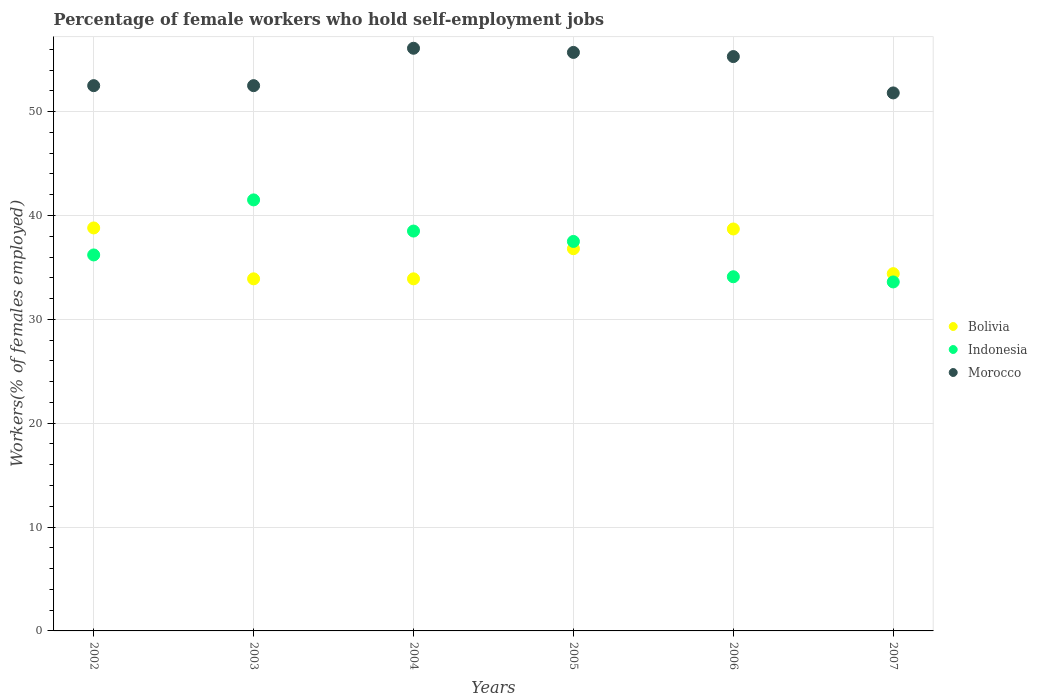Is the number of dotlines equal to the number of legend labels?
Ensure brevity in your answer.  Yes. What is the percentage of self-employed female workers in Morocco in 2002?
Your response must be concise. 52.5. Across all years, what is the maximum percentage of self-employed female workers in Bolivia?
Your answer should be compact. 38.8. Across all years, what is the minimum percentage of self-employed female workers in Indonesia?
Offer a very short reply. 33.6. In which year was the percentage of self-employed female workers in Bolivia maximum?
Your response must be concise. 2002. What is the total percentage of self-employed female workers in Bolivia in the graph?
Offer a terse response. 216.5. What is the difference between the percentage of self-employed female workers in Morocco in 2002 and that in 2006?
Your answer should be compact. -2.8. What is the difference between the percentage of self-employed female workers in Morocco in 2003 and the percentage of self-employed female workers in Indonesia in 2007?
Your answer should be compact. 18.9. What is the average percentage of self-employed female workers in Bolivia per year?
Ensure brevity in your answer.  36.08. In the year 2002, what is the difference between the percentage of self-employed female workers in Indonesia and percentage of self-employed female workers in Morocco?
Offer a very short reply. -16.3. In how many years, is the percentage of self-employed female workers in Bolivia greater than 10 %?
Provide a short and direct response. 6. What is the ratio of the percentage of self-employed female workers in Indonesia in 2003 to that in 2006?
Keep it short and to the point. 1.22. What is the difference between the highest and the second highest percentage of self-employed female workers in Bolivia?
Your answer should be compact. 0.1. What is the difference between the highest and the lowest percentage of self-employed female workers in Morocco?
Ensure brevity in your answer.  4.3. Does the percentage of self-employed female workers in Indonesia monotonically increase over the years?
Make the answer very short. No. Is the percentage of self-employed female workers in Morocco strictly greater than the percentage of self-employed female workers in Indonesia over the years?
Make the answer very short. Yes. Is the percentage of self-employed female workers in Indonesia strictly less than the percentage of self-employed female workers in Morocco over the years?
Keep it short and to the point. Yes. How many dotlines are there?
Your answer should be compact. 3. How many years are there in the graph?
Offer a very short reply. 6. Are the values on the major ticks of Y-axis written in scientific E-notation?
Your answer should be compact. No. Does the graph contain any zero values?
Your answer should be very brief. No. Does the graph contain grids?
Your answer should be very brief. Yes. Where does the legend appear in the graph?
Offer a very short reply. Center right. How many legend labels are there?
Give a very brief answer. 3. What is the title of the graph?
Your answer should be very brief. Percentage of female workers who hold self-employment jobs. What is the label or title of the Y-axis?
Keep it short and to the point. Workers(% of females employed). What is the Workers(% of females employed) of Bolivia in 2002?
Give a very brief answer. 38.8. What is the Workers(% of females employed) of Indonesia in 2002?
Make the answer very short. 36.2. What is the Workers(% of females employed) of Morocco in 2002?
Make the answer very short. 52.5. What is the Workers(% of females employed) in Bolivia in 2003?
Your response must be concise. 33.9. What is the Workers(% of females employed) of Indonesia in 2003?
Offer a terse response. 41.5. What is the Workers(% of females employed) of Morocco in 2003?
Ensure brevity in your answer.  52.5. What is the Workers(% of females employed) of Bolivia in 2004?
Your answer should be very brief. 33.9. What is the Workers(% of females employed) in Indonesia in 2004?
Provide a succinct answer. 38.5. What is the Workers(% of females employed) in Morocco in 2004?
Your answer should be very brief. 56.1. What is the Workers(% of females employed) in Bolivia in 2005?
Your answer should be very brief. 36.8. What is the Workers(% of females employed) in Indonesia in 2005?
Offer a terse response. 37.5. What is the Workers(% of females employed) in Morocco in 2005?
Offer a terse response. 55.7. What is the Workers(% of females employed) in Bolivia in 2006?
Provide a succinct answer. 38.7. What is the Workers(% of females employed) in Indonesia in 2006?
Keep it short and to the point. 34.1. What is the Workers(% of females employed) in Morocco in 2006?
Provide a succinct answer. 55.3. What is the Workers(% of females employed) in Bolivia in 2007?
Your response must be concise. 34.4. What is the Workers(% of females employed) in Indonesia in 2007?
Offer a very short reply. 33.6. What is the Workers(% of females employed) in Morocco in 2007?
Ensure brevity in your answer.  51.8. Across all years, what is the maximum Workers(% of females employed) in Bolivia?
Offer a very short reply. 38.8. Across all years, what is the maximum Workers(% of females employed) in Indonesia?
Give a very brief answer. 41.5. Across all years, what is the maximum Workers(% of females employed) in Morocco?
Ensure brevity in your answer.  56.1. Across all years, what is the minimum Workers(% of females employed) in Bolivia?
Your answer should be very brief. 33.9. Across all years, what is the minimum Workers(% of females employed) in Indonesia?
Provide a succinct answer. 33.6. Across all years, what is the minimum Workers(% of females employed) in Morocco?
Provide a short and direct response. 51.8. What is the total Workers(% of females employed) of Bolivia in the graph?
Provide a short and direct response. 216.5. What is the total Workers(% of females employed) in Indonesia in the graph?
Your answer should be very brief. 221.4. What is the total Workers(% of females employed) in Morocco in the graph?
Make the answer very short. 323.9. What is the difference between the Workers(% of females employed) in Indonesia in 2002 and that in 2003?
Your answer should be very brief. -5.3. What is the difference between the Workers(% of females employed) in Morocco in 2002 and that in 2003?
Keep it short and to the point. 0. What is the difference between the Workers(% of females employed) in Indonesia in 2002 and that in 2004?
Keep it short and to the point. -2.3. What is the difference between the Workers(% of females employed) in Morocco in 2002 and that in 2004?
Your answer should be very brief. -3.6. What is the difference between the Workers(% of females employed) of Indonesia in 2002 and that in 2005?
Make the answer very short. -1.3. What is the difference between the Workers(% of females employed) in Morocco in 2002 and that in 2005?
Your answer should be compact. -3.2. What is the difference between the Workers(% of females employed) in Bolivia in 2002 and that in 2006?
Your response must be concise. 0.1. What is the difference between the Workers(% of females employed) in Morocco in 2002 and that in 2006?
Ensure brevity in your answer.  -2.8. What is the difference between the Workers(% of females employed) of Bolivia in 2002 and that in 2007?
Your answer should be very brief. 4.4. What is the difference between the Workers(% of females employed) in Indonesia in 2002 and that in 2007?
Keep it short and to the point. 2.6. What is the difference between the Workers(% of females employed) of Morocco in 2002 and that in 2007?
Keep it short and to the point. 0.7. What is the difference between the Workers(% of females employed) of Bolivia in 2003 and that in 2004?
Provide a short and direct response. 0. What is the difference between the Workers(% of females employed) in Indonesia in 2003 and that in 2005?
Provide a short and direct response. 4. What is the difference between the Workers(% of females employed) of Morocco in 2003 and that in 2005?
Your answer should be very brief. -3.2. What is the difference between the Workers(% of females employed) of Indonesia in 2003 and that in 2006?
Your response must be concise. 7.4. What is the difference between the Workers(% of females employed) of Morocco in 2003 and that in 2006?
Make the answer very short. -2.8. What is the difference between the Workers(% of females employed) in Indonesia in 2003 and that in 2007?
Your answer should be compact. 7.9. What is the difference between the Workers(% of females employed) in Morocco in 2003 and that in 2007?
Offer a very short reply. 0.7. What is the difference between the Workers(% of females employed) in Morocco in 2004 and that in 2005?
Your answer should be compact. 0.4. What is the difference between the Workers(% of females employed) in Bolivia in 2004 and that in 2006?
Provide a short and direct response. -4.8. What is the difference between the Workers(% of females employed) in Indonesia in 2005 and that in 2006?
Provide a succinct answer. 3.4. What is the difference between the Workers(% of females employed) in Morocco in 2005 and that in 2006?
Ensure brevity in your answer.  0.4. What is the difference between the Workers(% of females employed) in Indonesia in 2005 and that in 2007?
Your response must be concise. 3.9. What is the difference between the Workers(% of females employed) in Bolivia in 2006 and that in 2007?
Offer a terse response. 4.3. What is the difference between the Workers(% of females employed) of Bolivia in 2002 and the Workers(% of females employed) of Indonesia in 2003?
Make the answer very short. -2.7. What is the difference between the Workers(% of females employed) of Bolivia in 2002 and the Workers(% of females employed) of Morocco in 2003?
Offer a very short reply. -13.7. What is the difference between the Workers(% of females employed) in Indonesia in 2002 and the Workers(% of females employed) in Morocco in 2003?
Your answer should be very brief. -16.3. What is the difference between the Workers(% of females employed) of Bolivia in 2002 and the Workers(% of females employed) of Indonesia in 2004?
Make the answer very short. 0.3. What is the difference between the Workers(% of females employed) of Bolivia in 2002 and the Workers(% of females employed) of Morocco in 2004?
Keep it short and to the point. -17.3. What is the difference between the Workers(% of females employed) of Indonesia in 2002 and the Workers(% of females employed) of Morocco in 2004?
Your answer should be very brief. -19.9. What is the difference between the Workers(% of females employed) of Bolivia in 2002 and the Workers(% of females employed) of Indonesia in 2005?
Provide a short and direct response. 1.3. What is the difference between the Workers(% of females employed) in Bolivia in 2002 and the Workers(% of females employed) in Morocco in 2005?
Your answer should be compact. -16.9. What is the difference between the Workers(% of females employed) of Indonesia in 2002 and the Workers(% of females employed) of Morocco in 2005?
Your answer should be compact. -19.5. What is the difference between the Workers(% of females employed) of Bolivia in 2002 and the Workers(% of females employed) of Indonesia in 2006?
Your answer should be very brief. 4.7. What is the difference between the Workers(% of females employed) in Bolivia in 2002 and the Workers(% of females employed) in Morocco in 2006?
Provide a short and direct response. -16.5. What is the difference between the Workers(% of females employed) in Indonesia in 2002 and the Workers(% of females employed) in Morocco in 2006?
Give a very brief answer. -19.1. What is the difference between the Workers(% of females employed) in Bolivia in 2002 and the Workers(% of females employed) in Morocco in 2007?
Give a very brief answer. -13. What is the difference between the Workers(% of females employed) of Indonesia in 2002 and the Workers(% of females employed) of Morocco in 2007?
Offer a very short reply. -15.6. What is the difference between the Workers(% of females employed) in Bolivia in 2003 and the Workers(% of females employed) in Morocco in 2004?
Make the answer very short. -22.2. What is the difference between the Workers(% of females employed) of Indonesia in 2003 and the Workers(% of females employed) of Morocco in 2004?
Ensure brevity in your answer.  -14.6. What is the difference between the Workers(% of females employed) of Bolivia in 2003 and the Workers(% of females employed) of Morocco in 2005?
Offer a terse response. -21.8. What is the difference between the Workers(% of females employed) of Bolivia in 2003 and the Workers(% of females employed) of Indonesia in 2006?
Your answer should be very brief. -0.2. What is the difference between the Workers(% of females employed) in Bolivia in 2003 and the Workers(% of females employed) in Morocco in 2006?
Your response must be concise. -21.4. What is the difference between the Workers(% of females employed) in Bolivia in 2003 and the Workers(% of females employed) in Morocco in 2007?
Your response must be concise. -17.9. What is the difference between the Workers(% of females employed) in Indonesia in 2003 and the Workers(% of females employed) in Morocco in 2007?
Make the answer very short. -10.3. What is the difference between the Workers(% of females employed) in Bolivia in 2004 and the Workers(% of females employed) in Morocco in 2005?
Your response must be concise. -21.8. What is the difference between the Workers(% of females employed) of Indonesia in 2004 and the Workers(% of females employed) of Morocco in 2005?
Your answer should be very brief. -17.2. What is the difference between the Workers(% of females employed) in Bolivia in 2004 and the Workers(% of females employed) in Indonesia in 2006?
Provide a succinct answer. -0.2. What is the difference between the Workers(% of females employed) of Bolivia in 2004 and the Workers(% of females employed) of Morocco in 2006?
Your answer should be compact. -21.4. What is the difference between the Workers(% of females employed) of Indonesia in 2004 and the Workers(% of females employed) of Morocco in 2006?
Give a very brief answer. -16.8. What is the difference between the Workers(% of females employed) of Bolivia in 2004 and the Workers(% of females employed) of Indonesia in 2007?
Make the answer very short. 0.3. What is the difference between the Workers(% of females employed) of Bolivia in 2004 and the Workers(% of females employed) of Morocco in 2007?
Your answer should be very brief. -17.9. What is the difference between the Workers(% of females employed) of Bolivia in 2005 and the Workers(% of females employed) of Morocco in 2006?
Your response must be concise. -18.5. What is the difference between the Workers(% of females employed) of Indonesia in 2005 and the Workers(% of females employed) of Morocco in 2006?
Provide a succinct answer. -17.8. What is the difference between the Workers(% of females employed) in Bolivia in 2005 and the Workers(% of females employed) in Morocco in 2007?
Provide a succinct answer. -15. What is the difference between the Workers(% of females employed) in Indonesia in 2005 and the Workers(% of females employed) in Morocco in 2007?
Give a very brief answer. -14.3. What is the difference between the Workers(% of females employed) of Bolivia in 2006 and the Workers(% of females employed) of Indonesia in 2007?
Keep it short and to the point. 5.1. What is the difference between the Workers(% of females employed) in Indonesia in 2006 and the Workers(% of females employed) in Morocco in 2007?
Provide a short and direct response. -17.7. What is the average Workers(% of females employed) of Bolivia per year?
Offer a terse response. 36.08. What is the average Workers(% of females employed) of Indonesia per year?
Give a very brief answer. 36.9. What is the average Workers(% of females employed) in Morocco per year?
Provide a succinct answer. 53.98. In the year 2002, what is the difference between the Workers(% of females employed) in Bolivia and Workers(% of females employed) in Indonesia?
Offer a terse response. 2.6. In the year 2002, what is the difference between the Workers(% of females employed) in Bolivia and Workers(% of females employed) in Morocco?
Provide a short and direct response. -13.7. In the year 2002, what is the difference between the Workers(% of females employed) of Indonesia and Workers(% of females employed) of Morocco?
Provide a short and direct response. -16.3. In the year 2003, what is the difference between the Workers(% of females employed) in Bolivia and Workers(% of females employed) in Morocco?
Keep it short and to the point. -18.6. In the year 2004, what is the difference between the Workers(% of females employed) in Bolivia and Workers(% of females employed) in Indonesia?
Your answer should be very brief. -4.6. In the year 2004, what is the difference between the Workers(% of females employed) of Bolivia and Workers(% of females employed) of Morocco?
Provide a succinct answer. -22.2. In the year 2004, what is the difference between the Workers(% of females employed) in Indonesia and Workers(% of females employed) in Morocco?
Offer a very short reply. -17.6. In the year 2005, what is the difference between the Workers(% of females employed) in Bolivia and Workers(% of females employed) in Indonesia?
Make the answer very short. -0.7. In the year 2005, what is the difference between the Workers(% of females employed) of Bolivia and Workers(% of females employed) of Morocco?
Ensure brevity in your answer.  -18.9. In the year 2005, what is the difference between the Workers(% of females employed) in Indonesia and Workers(% of females employed) in Morocco?
Make the answer very short. -18.2. In the year 2006, what is the difference between the Workers(% of females employed) in Bolivia and Workers(% of females employed) in Indonesia?
Your response must be concise. 4.6. In the year 2006, what is the difference between the Workers(% of females employed) in Bolivia and Workers(% of females employed) in Morocco?
Ensure brevity in your answer.  -16.6. In the year 2006, what is the difference between the Workers(% of females employed) of Indonesia and Workers(% of females employed) of Morocco?
Provide a succinct answer. -21.2. In the year 2007, what is the difference between the Workers(% of females employed) of Bolivia and Workers(% of females employed) of Indonesia?
Give a very brief answer. 0.8. In the year 2007, what is the difference between the Workers(% of females employed) in Bolivia and Workers(% of females employed) in Morocco?
Your response must be concise. -17.4. In the year 2007, what is the difference between the Workers(% of females employed) in Indonesia and Workers(% of females employed) in Morocco?
Your response must be concise. -18.2. What is the ratio of the Workers(% of females employed) in Bolivia in 2002 to that in 2003?
Keep it short and to the point. 1.14. What is the ratio of the Workers(% of females employed) of Indonesia in 2002 to that in 2003?
Offer a very short reply. 0.87. What is the ratio of the Workers(% of females employed) in Bolivia in 2002 to that in 2004?
Make the answer very short. 1.14. What is the ratio of the Workers(% of females employed) in Indonesia in 2002 to that in 2004?
Offer a very short reply. 0.94. What is the ratio of the Workers(% of females employed) of Morocco in 2002 to that in 2004?
Your answer should be compact. 0.94. What is the ratio of the Workers(% of females employed) of Bolivia in 2002 to that in 2005?
Give a very brief answer. 1.05. What is the ratio of the Workers(% of females employed) in Indonesia in 2002 to that in 2005?
Make the answer very short. 0.97. What is the ratio of the Workers(% of females employed) in Morocco in 2002 to that in 2005?
Offer a very short reply. 0.94. What is the ratio of the Workers(% of females employed) in Indonesia in 2002 to that in 2006?
Make the answer very short. 1.06. What is the ratio of the Workers(% of females employed) of Morocco in 2002 to that in 2006?
Make the answer very short. 0.95. What is the ratio of the Workers(% of females employed) of Bolivia in 2002 to that in 2007?
Give a very brief answer. 1.13. What is the ratio of the Workers(% of females employed) in Indonesia in 2002 to that in 2007?
Your response must be concise. 1.08. What is the ratio of the Workers(% of females employed) of Morocco in 2002 to that in 2007?
Keep it short and to the point. 1.01. What is the ratio of the Workers(% of females employed) of Indonesia in 2003 to that in 2004?
Offer a very short reply. 1.08. What is the ratio of the Workers(% of females employed) in Morocco in 2003 to that in 2004?
Offer a terse response. 0.94. What is the ratio of the Workers(% of females employed) in Bolivia in 2003 to that in 2005?
Provide a short and direct response. 0.92. What is the ratio of the Workers(% of females employed) in Indonesia in 2003 to that in 2005?
Make the answer very short. 1.11. What is the ratio of the Workers(% of females employed) in Morocco in 2003 to that in 2005?
Provide a succinct answer. 0.94. What is the ratio of the Workers(% of females employed) of Bolivia in 2003 to that in 2006?
Your answer should be very brief. 0.88. What is the ratio of the Workers(% of females employed) of Indonesia in 2003 to that in 2006?
Give a very brief answer. 1.22. What is the ratio of the Workers(% of females employed) of Morocco in 2003 to that in 2006?
Keep it short and to the point. 0.95. What is the ratio of the Workers(% of females employed) of Bolivia in 2003 to that in 2007?
Offer a terse response. 0.99. What is the ratio of the Workers(% of females employed) in Indonesia in 2003 to that in 2007?
Your response must be concise. 1.24. What is the ratio of the Workers(% of females employed) of Morocco in 2003 to that in 2007?
Provide a short and direct response. 1.01. What is the ratio of the Workers(% of females employed) in Bolivia in 2004 to that in 2005?
Provide a succinct answer. 0.92. What is the ratio of the Workers(% of females employed) of Indonesia in 2004 to that in 2005?
Offer a very short reply. 1.03. What is the ratio of the Workers(% of females employed) of Bolivia in 2004 to that in 2006?
Keep it short and to the point. 0.88. What is the ratio of the Workers(% of females employed) of Indonesia in 2004 to that in 2006?
Your answer should be compact. 1.13. What is the ratio of the Workers(% of females employed) of Morocco in 2004 to that in 2006?
Give a very brief answer. 1.01. What is the ratio of the Workers(% of females employed) of Bolivia in 2004 to that in 2007?
Your answer should be compact. 0.99. What is the ratio of the Workers(% of females employed) in Indonesia in 2004 to that in 2007?
Ensure brevity in your answer.  1.15. What is the ratio of the Workers(% of females employed) of Morocco in 2004 to that in 2007?
Your answer should be very brief. 1.08. What is the ratio of the Workers(% of females employed) in Bolivia in 2005 to that in 2006?
Give a very brief answer. 0.95. What is the ratio of the Workers(% of females employed) of Indonesia in 2005 to that in 2006?
Your response must be concise. 1.1. What is the ratio of the Workers(% of females employed) in Bolivia in 2005 to that in 2007?
Offer a very short reply. 1.07. What is the ratio of the Workers(% of females employed) in Indonesia in 2005 to that in 2007?
Your response must be concise. 1.12. What is the ratio of the Workers(% of females employed) in Morocco in 2005 to that in 2007?
Your answer should be very brief. 1.08. What is the ratio of the Workers(% of females employed) of Bolivia in 2006 to that in 2007?
Your response must be concise. 1.12. What is the ratio of the Workers(% of females employed) in Indonesia in 2006 to that in 2007?
Offer a very short reply. 1.01. What is the ratio of the Workers(% of females employed) of Morocco in 2006 to that in 2007?
Offer a very short reply. 1.07. What is the difference between the highest and the second highest Workers(% of females employed) of Morocco?
Ensure brevity in your answer.  0.4. 